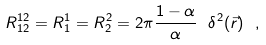Convert formula to latex. <formula><loc_0><loc_0><loc_500><loc_500>R ^ { 1 2 } _ { 1 2 } = R ^ { 1 } _ { 1 } = R ^ { 2 } _ { 2 } = 2 \pi \frac { 1 - \alpha } { \alpha } \ \delta ^ { 2 } ( \vec { r } ) \ ,</formula> 